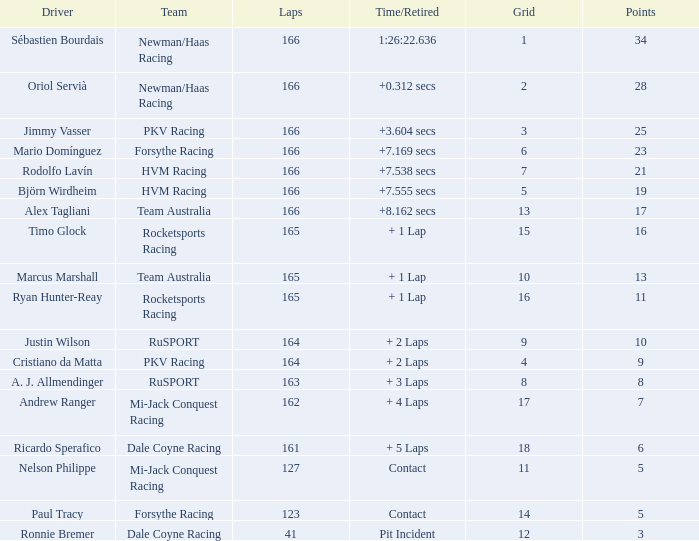538 secs? 21.0. Would you be able to parse every entry in this table? {'header': ['Driver', 'Team', 'Laps', 'Time/Retired', 'Grid', 'Points'], 'rows': [['Sébastien Bourdais', 'Newman/Haas Racing', '166', '1:26:22.636', '1', '34'], ['Oriol Servià', 'Newman/Haas Racing', '166', '+0.312 secs', '2', '28'], ['Jimmy Vasser', 'PKV Racing', '166', '+3.604 secs', '3', '25'], ['Mario Domínguez', 'Forsythe Racing', '166', '+7.169 secs', '6', '23'], ['Rodolfo Lavín', 'HVM Racing', '166', '+7.538 secs', '7', '21'], ['Björn Wirdheim', 'HVM Racing', '166', '+7.555 secs', '5', '19'], ['Alex Tagliani', 'Team Australia', '166', '+8.162 secs', '13', '17'], ['Timo Glock', 'Rocketsports Racing', '165', '+ 1 Lap', '15', '16'], ['Marcus Marshall', 'Team Australia', '165', '+ 1 Lap', '10', '13'], ['Ryan Hunter-Reay', 'Rocketsports Racing', '165', '+ 1 Lap', '16', '11'], ['Justin Wilson', 'RuSPORT', '164', '+ 2 Laps', '9', '10'], ['Cristiano da Matta', 'PKV Racing', '164', '+ 2 Laps', '4', '9'], ['A. J. Allmendinger', 'RuSPORT', '163', '+ 3 Laps', '8', '8'], ['Andrew Ranger', 'Mi-Jack Conquest Racing', '162', '+ 4 Laps', '17', '7'], ['Ricardo Sperafico', 'Dale Coyne Racing', '161', '+ 5 Laps', '18', '6'], ['Nelson Philippe', 'Mi-Jack Conquest Racing', '127', 'Contact', '11', '5'], ['Paul Tracy', 'Forsythe Racing', '123', 'Contact', '14', '5'], ['Ronnie Bremer', 'Dale Coyne Racing', '41', 'Pit Incident', '12', '3']]} 